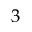Convert formula to latex. <formula><loc_0><loc_0><loc_500><loc_500>3</formula> 